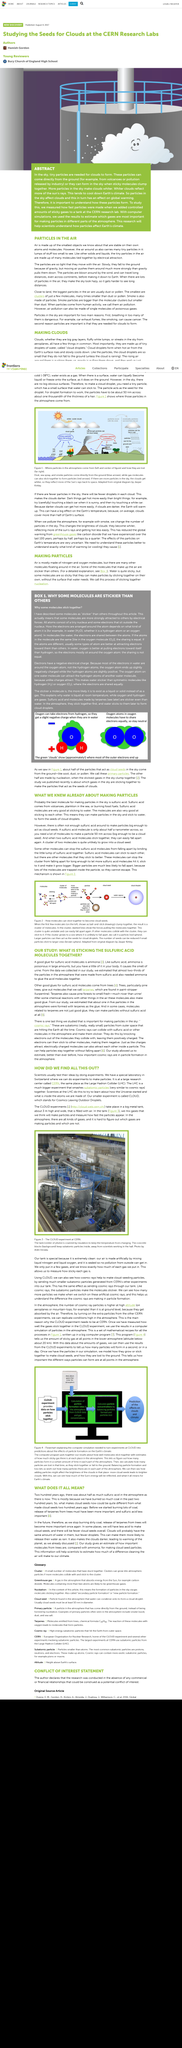Indicate a few pertinent items in this graphic. The figure shows the CLOUD experiment at CERN, which demonstrates the impact of atmospheric aerosols on cloud formation. Sulfuric acid molecules are approximately half a nanometer in width. Yes, there are many other molecules floating around in the air. The process of sticking molecules together is called nucleation. Air is made up of mostly nitrogen and oxygen molecules, according to scientific studies. 